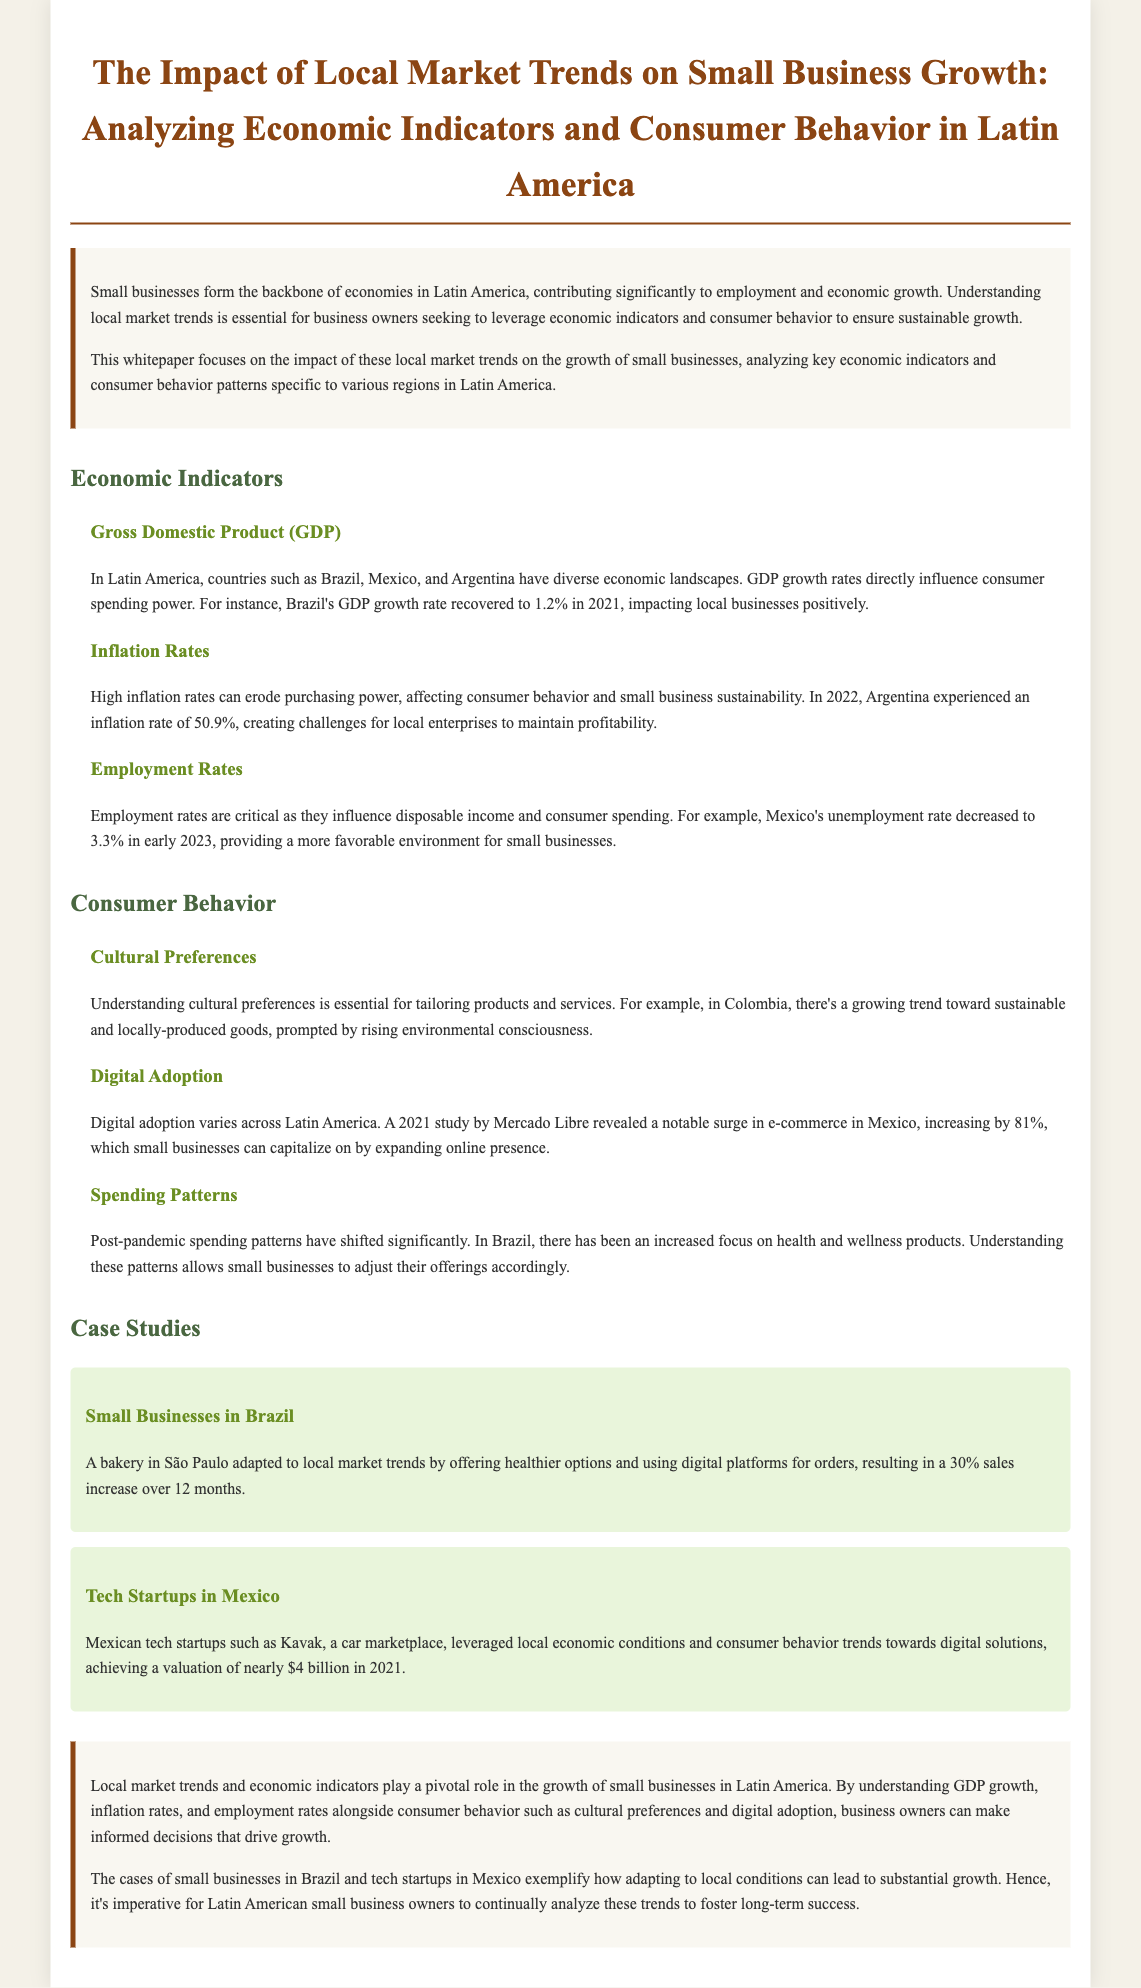What is the primary focus of the whitepaper? The whitepaper focuses on the impact of local market trends on small business growth in Latin America.
Answer: Impact of local market trends on small business growth in Latin America What was Brazil's GDP growth rate in 2021? The document states that Brazil's GDP growth rate recovered to 1.2% in 2021.
Answer: 1.2% What inflation rate did Argentina experience in 2022? It mentions that Argentina experienced an inflation rate of 50.9% in 2022.
Answer: 50.9% Which country saw an unemployment rate decrease to 3.3% in early 2023? The text specifies that Mexico's unemployment rate decreased to 3.3% in early 2023.
Answer: Mexico What cultural trend is growing in Colombia? The document highlights a growing trend toward sustainable and locally-produced goods in Colombia.
Answer: Sustainable and locally-produced goods What was the increase percentage in e-commerce in Mexico as of 2021? A study cited indicates that e-commerce in Mexico increased by 81% in 2021.
Answer: 81% What type of products has seen increased focus in Brazil post-pandemic? The document mentions an increased focus on health and wellness products in Brazil.
Answer: Health and wellness products What was the sales increase percentage for a bakery in São Paulo? The bakery adapted its business strategy and saw a 30% sales increase over 12 months.
Answer: 30% What was the valuation achieved by Kavak in 2021? The document states that Kavak achieved a valuation of nearly $4 billion in 2021.
Answer: Nearly $4 billion 